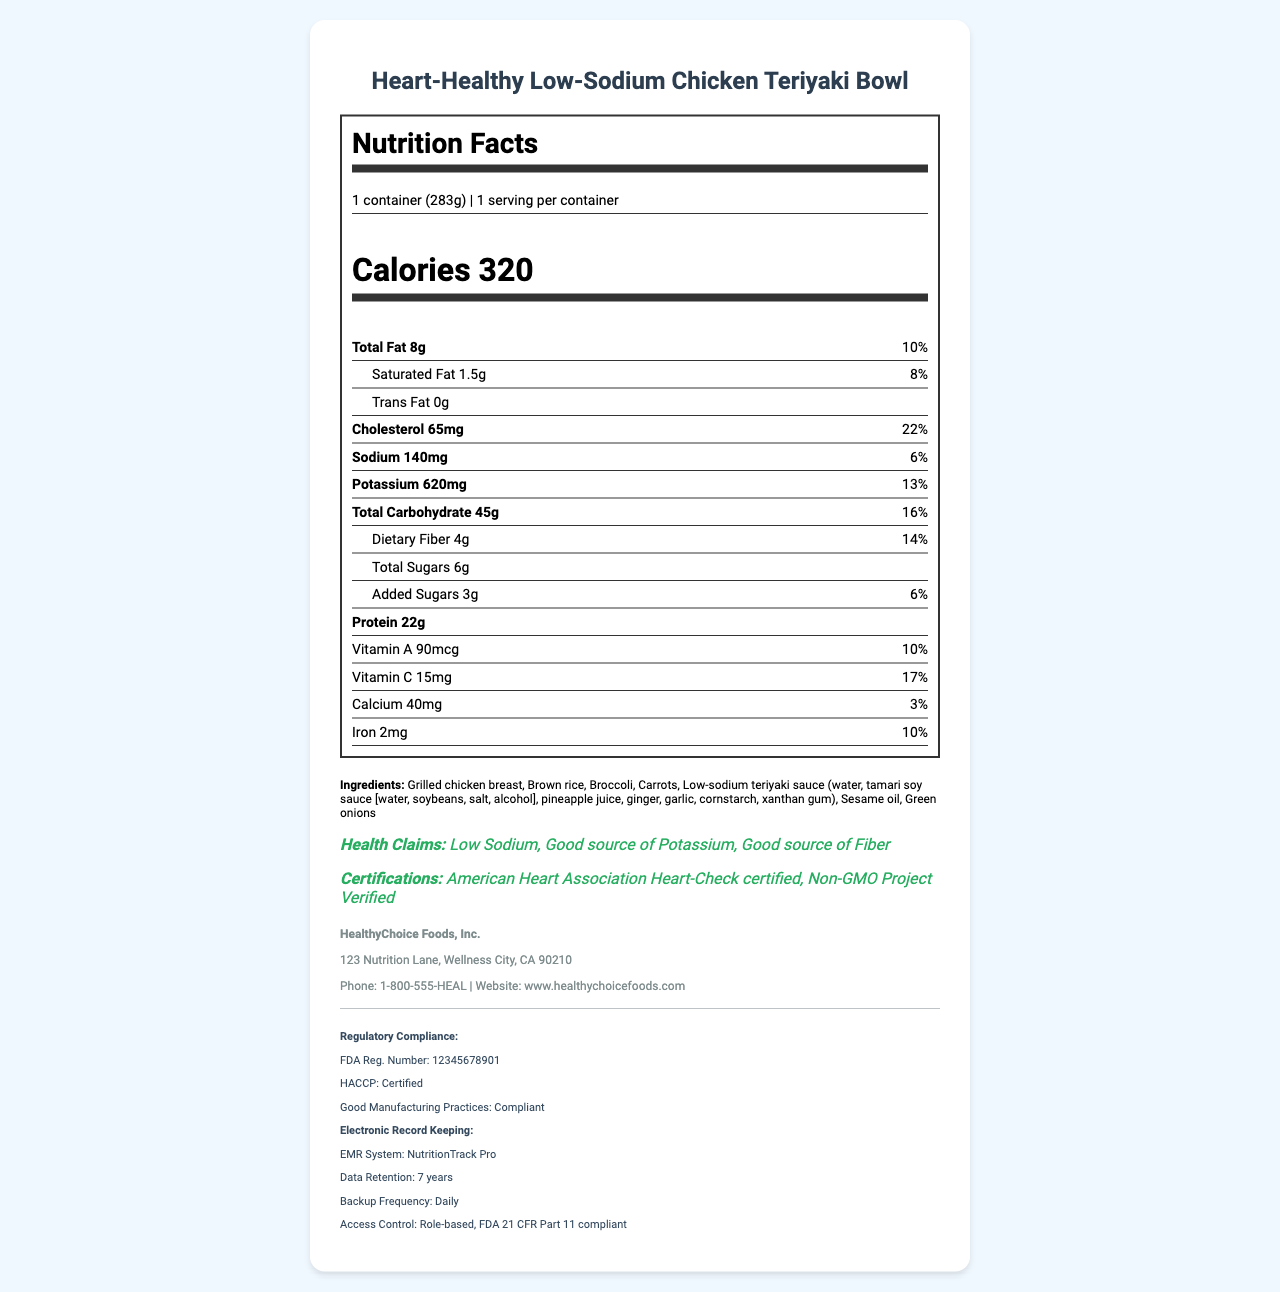What is the serving size of the Heart-Healthy Low-Sodium Chicken Teriyaki Bowl? The Serving Size section specifies "1 container (283g)".
Answer: 1 container (283g) How many calories are in one serving of the meal? The Calories section lists "320" calories for the serving size of 1 container.
Answer: 320 What are the total sugars in the meal? The nutrient breakdown lists "Total Sugars" as "6g".
Answer: 6g How much sodium does the meal contain? The Sodium section specifies "140mg".
Answer: 140mg What is the daily value percentage of potassium in the meal? The Potassium section indicates a daily value of "13%".
Answer: 13% How many grams of protein are in the meal? The nutrient breakdown lists "Protein" as "22g".
Answer: 22g Which of the following is NOT included in the health claims for this meal? A. Low Sodium B. Good source of Potassium C. Good source of Protein D. Good source of Fiber The Health Claims section lists "Low Sodium", "Good source of Potassium", and "Good source of Fiber"; "Good source of Protein" is not included.
Answer: C Which certification does this product have? A. USDA Organic B. Non-GMO Project Verified C. Gluten-Free Certified D. Kosher The Certifications section lists "Non-GMO Project Verified".
Answer: B Is the meal certified by the American Heart Association? The Certifications section lists "American Heart Association Heart-Check certified".
Answer: Yes Summarize the key nutritional and health information of the Heart-Healthy Low-Sodium Chicken Teriyaki Bowl. The document outlines the key nutritional facts, including low sodium and good potassium sources, with certifications ensuring quality and health benefits.
Answer: This meal is aimed at those looking for low-sodium options and offers a good source of potassium and fiber. It has 320 calories per container, 8g of total fat, 140mg of sodium, 620mg of potassium, 45g of carbohydrates, 4g of dietary fiber, and 22g of protein. Additionally, it is certified by the American Heart Association and the Non-GMO Project. Ingredients include grilled chicken, brown rice, and low-sodium teriyaki sauce. What is the company's FDA registration number? The Regulatory Compliance section lists the FDA Reg. Number as "12345678901".
Answer: 12345678901 Who is the manufacturer of the meal? The Manufacturer Info section specifies "HealthyChoice Foods, Inc.".
Answer: HealthyChoice Foods, Inc. How much trans fat does the meal contain? The Trans Fat section specifies "0g".
Answer: 0g Does the meal contain soy? The Allergens section lists "Soy".
Answer: Yes Can the preparation instructions for the meal be found in the document? The document contains preparation instructions in the "Preparation Instructions" section.
Answer: Yes What flavors are in the low-sodium teriyaki sauce? The document lists the ingredients but does not describe the flavors of the low-sodium teriyaki sauce.
Answer: Cannot be determined 